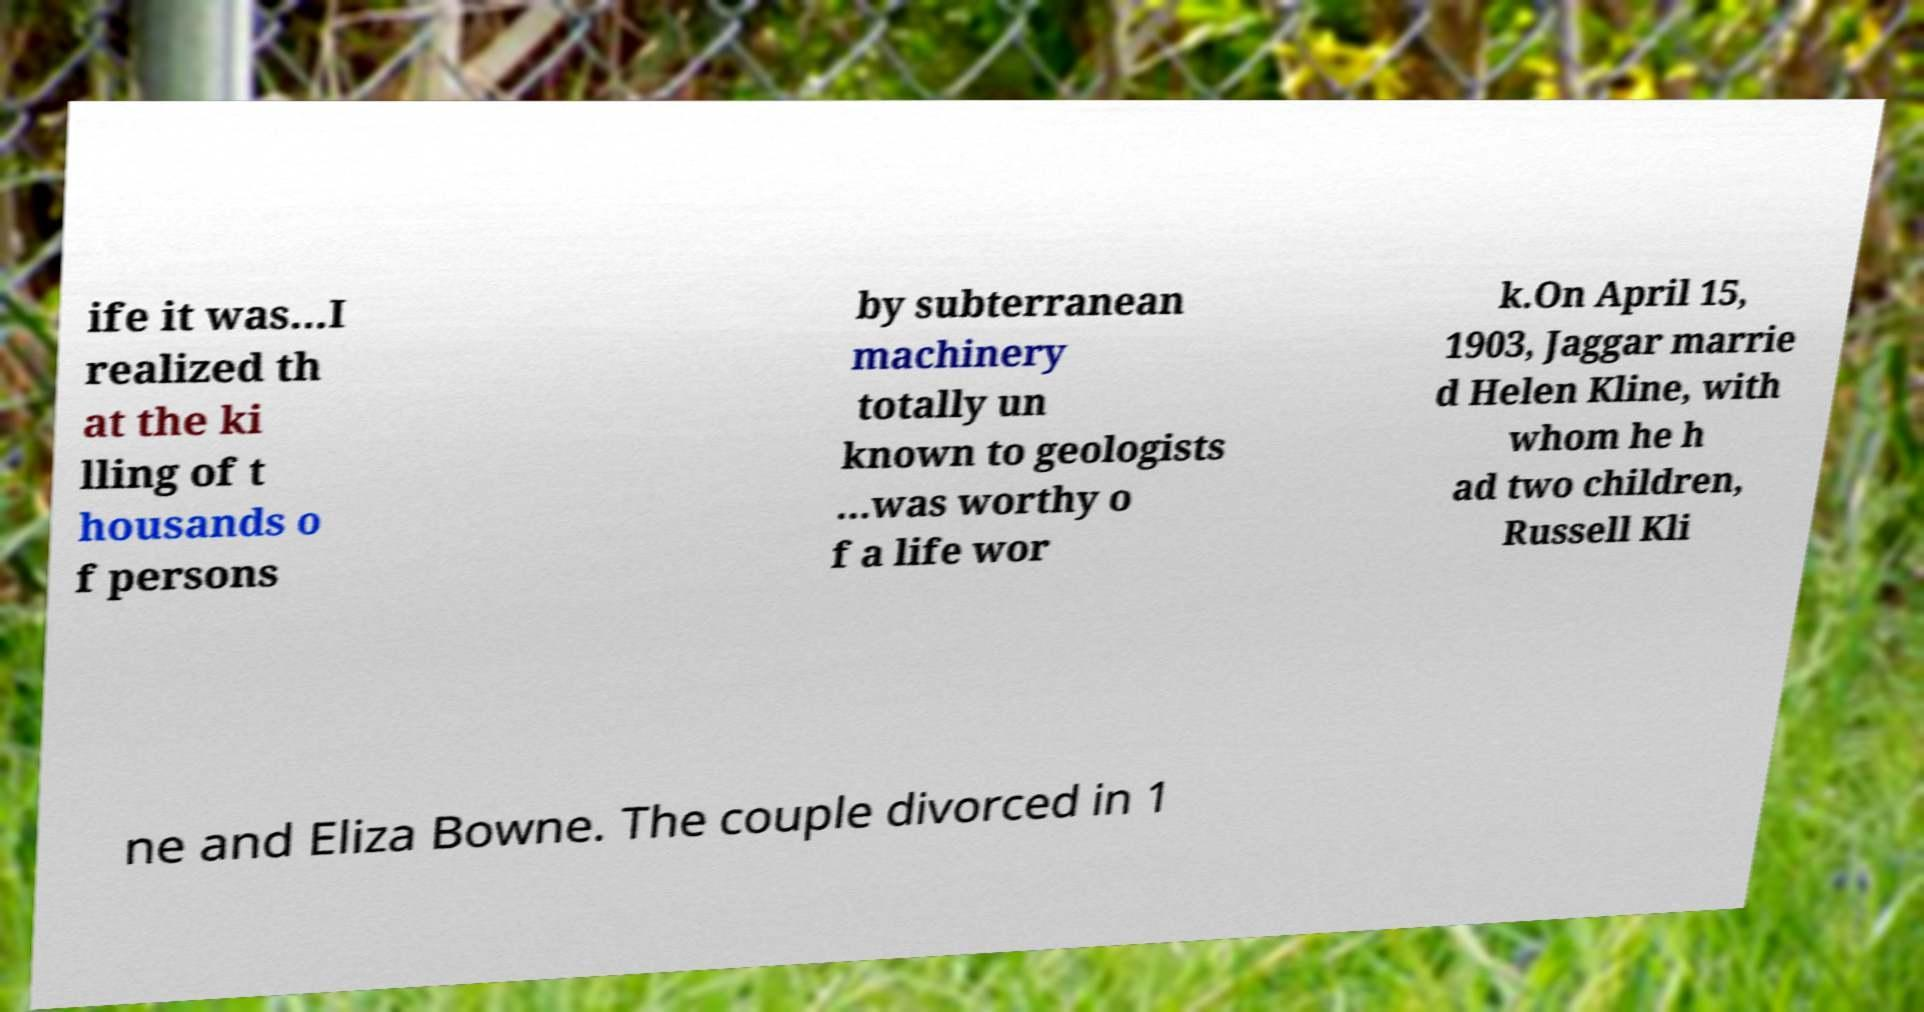Please read and relay the text visible in this image. What does it say? ife it was...I realized th at the ki lling of t housands o f persons by subterranean machinery totally un known to geologists ...was worthy o f a life wor k.On April 15, 1903, Jaggar marrie d Helen Kline, with whom he h ad two children, Russell Kli ne and Eliza Bowne. The couple divorced in 1 